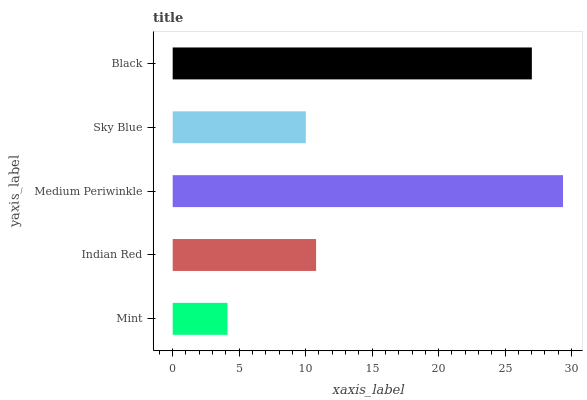Is Mint the minimum?
Answer yes or no. Yes. Is Medium Periwinkle the maximum?
Answer yes or no. Yes. Is Indian Red the minimum?
Answer yes or no. No. Is Indian Red the maximum?
Answer yes or no. No. Is Indian Red greater than Mint?
Answer yes or no. Yes. Is Mint less than Indian Red?
Answer yes or no. Yes. Is Mint greater than Indian Red?
Answer yes or no. No. Is Indian Red less than Mint?
Answer yes or no. No. Is Indian Red the high median?
Answer yes or no. Yes. Is Indian Red the low median?
Answer yes or no. Yes. Is Mint the high median?
Answer yes or no. No. Is Medium Periwinkle the low median?
Answer yes or no. No. 